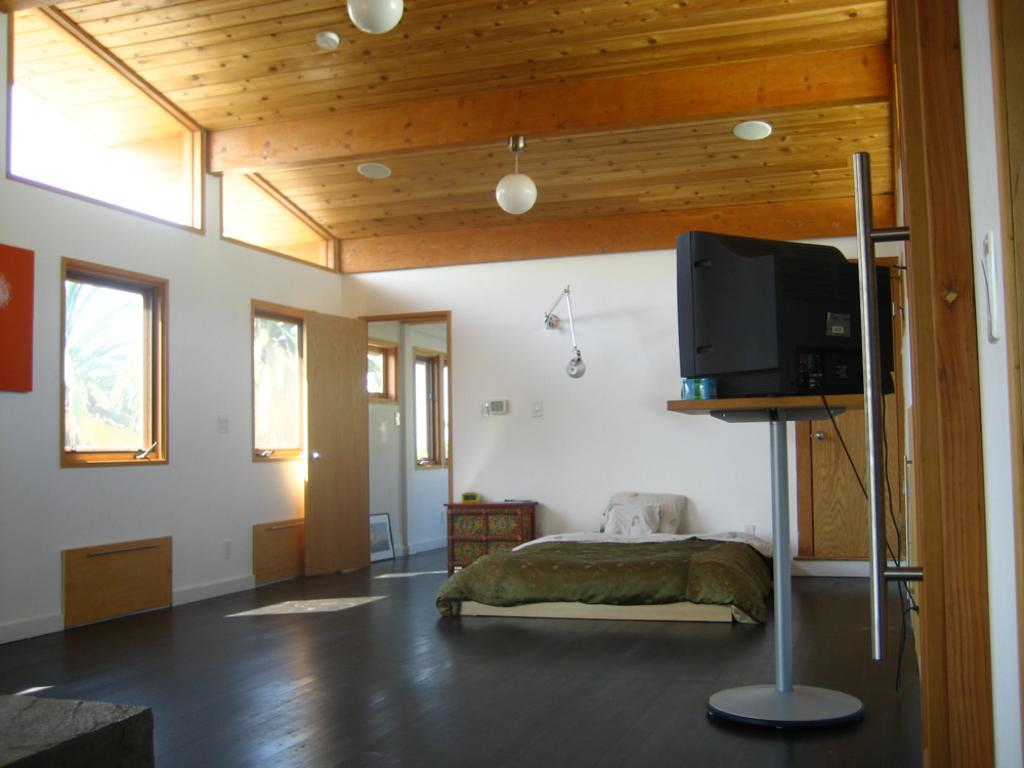What type of furniture is present in the room? There is a bed, a cupboard, and a television with a stand in the room. What can be found on the bed? The bed has pillows. How can one enter or exit the room? There is a door in the room. What provides natural light in the room? There are windows in the room. What provides artificial light in the room? There are ceiling lights in the room. What is the room enclosed by? There is a roof and walls in the room. What is the surface on which the furniture and other objects rest? There is a floor in the room. What type of knife is used to cut the roof in the room? There is no knife or roof-cutting activity present in the image. The room has a roof, but it is not being cut or altered in any way. 